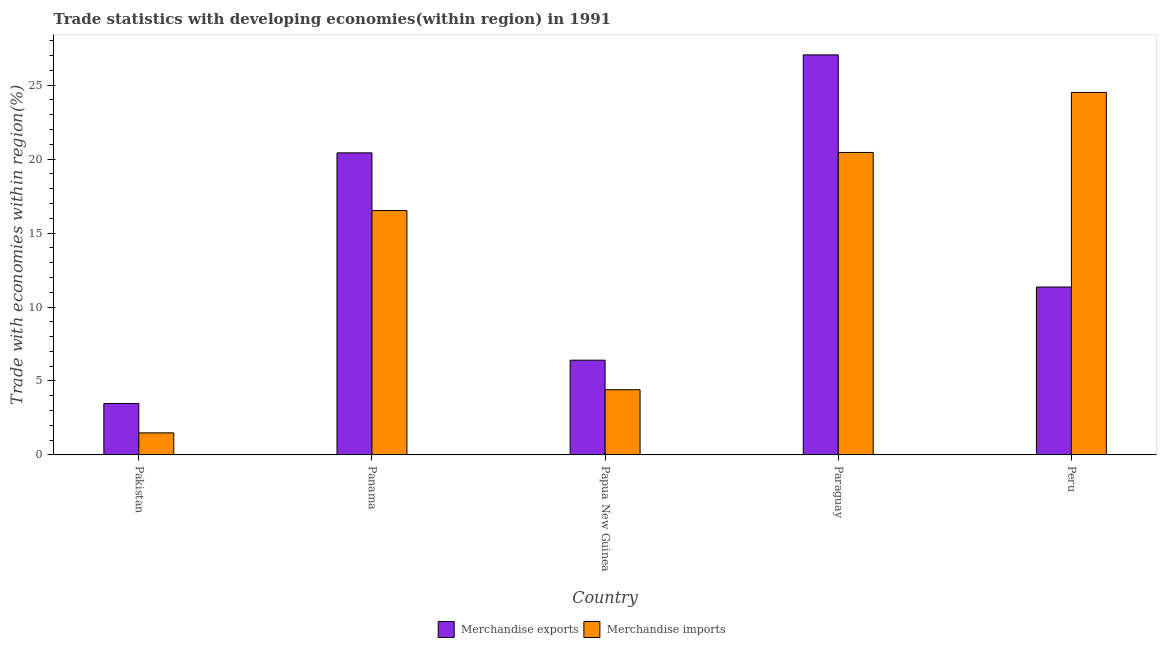Are the number of bars on each tick of the X-axis equal?
Provide a short and direct response. Yes. How many bars are there on the 4th tick from the left?
Offer a very short reply. 2. What is the label of the 2nd group of bars from the left?
Offer a terse response. Panama. What is the merchandise imports in Pakistan?
Keep it short and to the point. 1.49. Across all countries, what is the maximum merchandise exports?
Provide a short and direct response. 27.05. Across all countries, what is the minimum merchandise imports?
Your answer should be very brief. 1.49. What is the total merchandise exports in the graph?
Your answer should be very brief. 68.7. What is the difference between the merchandise exports in Papua New Guinea and that in Paraguay?
Provide a short and direct response. -20.64. What is the difference between the merchandise exports in Papua New Guinea and the merchandise imports in Pakistan?
Offer a very short reply. 4.91. What is the average merchandise imports per country?
Keep it short and to the point. 13.48. What is the difference between the merchandise exports and merchandise imports in Pakistan?
Ensure brevity in your answer.  1.99. What is the ratio of the merchandise exports in Papua New Guinea to that in Paraguay?
Provide a short and direct response. 0.24. Is the merchandise imports in Pakistan less than that in Paraguay?
Provide a succinct answer. Yes. What is the difference between the highest and the second highest merchandise imports?
Your response must be concise. 4.06. What is the difference between the highest and the lowest merchandise imports?
Offer a very short reply. 23.02. In how many countries, is the merchandise exports greater than the average merchandise exports taken over all countries?
Offer a very short reply. 2. Is the sum of the merchandise imports in Panama and Papua New Guinea greater than the maximum merchandise exports across all countries?
Give a very brief answer. No. What does the 2nd bar from the right in Peru represents?
Give a very brief answer. Merchandise exports. Are all the bars in the graph horizontal?
Your answer should be compact. No. What is the difference between two consecutive major ticks on the Y-axis?
Ensure brevity in your answer.  5. Are the values on the major ticks of Y-axis written in scientific E-notation?
Offer a very short reply. No. Does the graph contain any zero values?
Offer a very short reply. No. Does the graph contain grids?
Provide a succinct answer. No. Where does the legend appear in the graph?
Your answer should be very brief. Bottom center. How many legend labels are there?
Ensure brevity in your answer.  2. How are the legend labels stacked?
Give a very brief answer. Horizontal. What is the title of the graph?
Your answer should be compact. Trade statistics with developing economies(within region) in 1991. What is the label or title of the X-axis?
Your response must be concise. Country. What is the label or title of the Y-axis?
Make the answer very short. Trade with economies within region(%). What is the Trade with economies within region(%) of Merchandise exports in Pakistan?
Offer a terse response. 3.48. What is the Trade with economies within region(%) in Merchandise imports in Pakistan?
Provide a short and direct response. 1.49. What is the Trade with economies within region(%) of Merchandise exports in Panama?
Offer a terse response. 20.42. What is the Trade with economies within region(%) in Merchandise imports in Panama?
Keep it short and to the point. 16.52. What is the Trade with economies within region(%) of Merchandise exports in Papua New Guinea?
Your answer should be very brief. 6.41. What is the Trade with economies within region(%) in Merchandise imports in Papua New Guinea?
Provide a succinct answer. 4.41. What is the Trade with economies within region(%) in Merchandise exports in Paraguay?
Give a very brief answer. 27.05. What is the Trade with economies within region(%) in Merchandise imports in Paraguay?
Ensure brevity in your answer.  20.45. What is the Trade with economies within region(%) of Merchandise exports in Peru?
Your answer should be compact. 11.35. What is the Trade with economies within region(%) of Merchandise imports in Peru?
Make the answer very short. 24.51. Across all countries, what is the maximum Trade with economies within region(%) of Merchandise exports?
Provide a succinct answer. 27.05. Across all countries, what is the maximum Trade with economies within region(%) in Merchandise imports?
Your answer should be very brief. 24.51. Across all countries, what is the minimum Trade with economies within region(%) of Merchandise exports?
Ensure brevity in your answer.  3.48. Across all countries, what is the minimum Trade with economies within region(%) in Merchandise imports?
Offer a terse response. 1.49. What is the total Trade with economies within region(%) of Merchandise exports in the graph?
Offer a very short reply. 68.7. What is the total Trade with economies within region(%) of Merchandise imports in the graph?
Make the answer very short. 67.38. What is the difference between the Trade with economies within region(%) of Merchandise exports in Pakistan and that in Panama?
Offer a terse response. -16.95. What is the difference between the Trade with economies within region(%) in Merchandise imports in Pakistan and that in Panama?
Make the answer very short. -15.03. What is the difference between the Trade with economies within region(%) of Merchandise exports in Pakistan and that in Papua New Guinea?
Your answer should be very brief. -2.93. What is the difference between the Trade with economies within region(%) in Merchandise imports in Pakistan and that in Papua New Guinea?
Give a very brief answer. -2.92. What is the difference between the Trade with economies within region(%) in Merchandise exports in Pakistan and that in Paraguay?
Your response must be concise. -23.57. What is the difference between the Trade with economies within region(%) of Merchandise imports in Pakistan and that in Paraguay?
Ensure brevity in your answer.  -18.96. What is the difference between the Trade with economies within region(%) of Merchandise exports in Pakistan and that in Peru?
Keep it short and to the point. -7.87. What is the difference between the Trade with economies within region(%) of Merchandise imports in Pakistan and that in Peru?
Make the answer very short. -23.02. What is the difference between the Trade with economies within region(%) in Merchandise exports in Panama and that in Papua New Guinea?
Your answer should be very brief. 14.02. What is the difference between the Trade with economies within region(%) in Merchandise imports in Panama and that in Papua New Guinea?
Your answer should be compact. 12.11. What is the difference between the Trade with economies within region(%) in Merchandise exports in Panama and that in Paraguay?
Offer a terse response. -6.62. What is the difference between the Trade with economies within region(%) in Merchandise imports in Panama and that in Paraguay?
Make the answer very short. -3.93. What is the difference between the Trade with economies within region(%) of Merchandise exports in Panama and that in Peru?
Make the answer very short. 9.07. What is the difference between the Trade with economies within region(%) of Merchandise imports in Panama and that in Peru?
Provide a short and direct response. -7.99. What is the difference between the Trade with economies within region(%) of Merchandise exports in Papua New Guinea and that in Paraguay?
Offer a terse response. -20.64. What is the difference between the Trade with economies within region(%) of Merchandise imports in Papua New Guinea and that in Paraguay?
Offer a terse response. -16.04. What is the difference between the Trade with economies within region(%) of Merchandise exports in Papua New Guinea and that in Peru?
Give a very brief answer. -4.95. What is the difference between the Trade with economies within region(%) in Merchandise imports in Papua New Guinea and that in Peru?
Your answer should be very brief. -20.1. What is the difference between the Trade with economies within region(%) in Merchandise exports in Paraguay and that in Peru?
Make the answer very short. 15.7. What is the difference between the Trade with economies within region(%) of Merchandise imports in Paraguay and that in Peru?
Make the answer very short. -4.06. What is the difference between the Trade with economies within region(%) of Merchandise exports in Pakistan and the Trade with economies within region(%) of Merchandise imports in Panama?
Your answer should be very brief. -13.04. What is the difference between the Trade with economies within region(%) of Merchandise exports in Pakistan and the Trade with economies within region(%) of Merchandise imports in Papua New Guinea?
Your answer should be compact. -0.93. What is the difference between the Trade with economies within region(%) in Merchandise exports in Pakistan and the Trade with economies within region(%) in Merchandise imports in Paraguay?
Your answer should be compact. -16.97. What is the difference between the Trade with economies within region(%) of Merchandise exports in Pakistan and the Trade with economies within region(%) of Merchandise imports in Peru?
Make the answer very short. -21.03. What is the difference between the Trade with economies within region(%) in Merchandise exports in Panama and the Trade with economies within region(%) in Merchandise imports in Papua New Guinea?
Provide a short and direct response. 16.01. What is the difference between the Trade with economies within region(%) in Merchandise exports in Panama and the Trade with economies within region(%) in Merchandise imports in Paraguay?
Give a very brief answer. -0.03. What is the difference between the Trade with economies within region(%) in Merchandise exports in Panama and the Trade with economies within region(%) in Merchandise imports in Peru?
Offer a very short reply. -4.08. What is the difference between the Trade with economies within region(%) of Merchandise exports in Papua New Guinea and the Trade with economies within region(%) of Merchandise imports in Paraguay?
Provide a short and direct response. -14.04. What is the difference between the Trade with economies within region(%) in Merchandise exports in Papua New Guinea and the Trade with economies within region(%) in Merchandise imports in Peru?
Provide a succinct answer. -18.1. What is the difference between the Trade with economies within region(%) of Merchandise exports in Paraguay and the Trade with economies within region(%) of Merchandise imports in Peru?
Your answer should be very brief. 2.54. What is the average Trade with economies within region(%) of Merchandise exports per country?
Provide a succinct answer. 13.74. What is the average Trade with economies within region(%) in Merchandise imports per country?
Provide a succinct answer. 13.48. What is the difference between the Trade with economies within region(%) of Merchandise exports and Trade with economies within region(%) of Merchandise imports in Pakistan?
Keep it short and to the point. 1.99. What is the difference between the Trade with economies within region(%) in Merchandise exports and Trade with economies within region(%) in Merchandise imports in Panama?
Your answer should be very brief. 3.9. What is the difference between the Trade with economies within region(%) of Merchandise exports and Trade with economies within region(%) of Merchandise imports in Papua New Guinea?
Your response must be concise. 2. What is the difference between the Trade with economies within region(%) in Merchandise exports and Trade with economies within region(%) in Merchandise imports in Paraguay?
Ensure brevity in your answer.  6.6. What is the difference between the Trade with economies within region(%) in Merchandise exports and Trade with economies within region(%) in Merchandise imports in Peru?
Give a very brief answer. -13.16. What is the ratio of the Trade with economies within region(%) of Merchandise exports in Pakistan to that in Panama?
Your response must be concise. 0.17. What is the ratio of the Trade with economies within region(%) in Merchandise imports in Pakistan to that in Panama?
Your response must be concise. 0.09. What is the ratio of the Trade with economies within region(%) in Merchandise exports in Pakistan to that in Papua New Guinea?
Your response must be concise. 0.54. What is the ratio of the Trade with economies within region(%) in Merchandise imports in Pakistan to that in Papua New Guinea?
Offer a terse response. 0.34. What is the ratio of the Trade with economies within region(%) of Merchandise exports in Pakistan to that in Paraguay?
Your response must be concise. 0.13. What is the ratio of the Trade with economies within region(%) in Merchandise imports in Pakistan to that in Paraguay?
Your answer should be compact. 0.07. What is the ratio of the Trade with economies within region(%) in Merchandise exports in Pakistan to that in Peru?
Give a very brief answer. 0.31. What is the ratio of the Trade with economies within region(%) of Merchandise imports in Pakistan to that in Peru?
Provide a short and direct response. 0.06. What is the ratio of the Trade with economies within region(%) in Merchandise exports in Panama to that in Papua New Guinea?
Make the answer very short. 3.19. What is the ratio of the Trade with economies within region(%) of Merchandise imports in Panama to that in Papua New Guinea?
Your answer should be compact. 3.75. What is the ratio of the Trade with economies within region(%) of Merchandise exports in Panama to that in Paraguay?
Ensure brevity in your answer.  0.76. What is the ratio of the Trade with economies within region(%) of Merchandise imports in Panama to that in Paraguay?
Provide a short and direct response. 0.81. What is the ratio of the Trade with economies within region(%) of Merchandise exports in Panama to that in Peru?
Keep it short and to the point. 1.8. What is the ratio of the Trade with economies within region(%) in Merchandise imports in Panama to that in Peru?
Offer a terse response. 0.67. What is the ratio of the Trade with economies within region(%) of Merchandise exports in Papua New Guinea to that in Paraguay?
Offer a very short reply. 0.24. What is the ratio of the Trade with economies within region(%) in Merchandise imports in Papua New Guinea to that in Paraguay?
Provide a succinct answer. 0.22. What is the ratio of the Trade with economies within region(%) of Merchandise exports in Papua New Guinea to that in Peru?
Make the answer very short. 0.56. What is the ratio of the Trade with economies within region(%) in Merchandise imports in Papua New Guinea to that in Peru?
Offer a very short reply. 0.18. What is the ratio of the Trade with economies within region(%) of Merchandise exports in Paraguay to that in Peru?
Provide a succinct answer. 2.38. What is the ratio of the Trade with economies within region(%) in Merchandise imports in Paraguay to that in Peru?
Provide a short and direct response. 0.83. What is the difference between the highest and the second highest Trade with economies within region(%) of Merchandise exports?
Your answer should be compact. 6.62. What is the difference between the highest and the second highest Trade with economies within region(%) in Merchandise imports?
Your response must be concise. 4.06. What is the difference between the highest and the lowest Trade with economies within region(%) in Merchandise exports?
Provide a short and direct response. 23.57. What is the difference between the highest and the lowest Trade with economies within region(%) in Merchandise imports?
Ensure brevity in your answer.  23.02. 